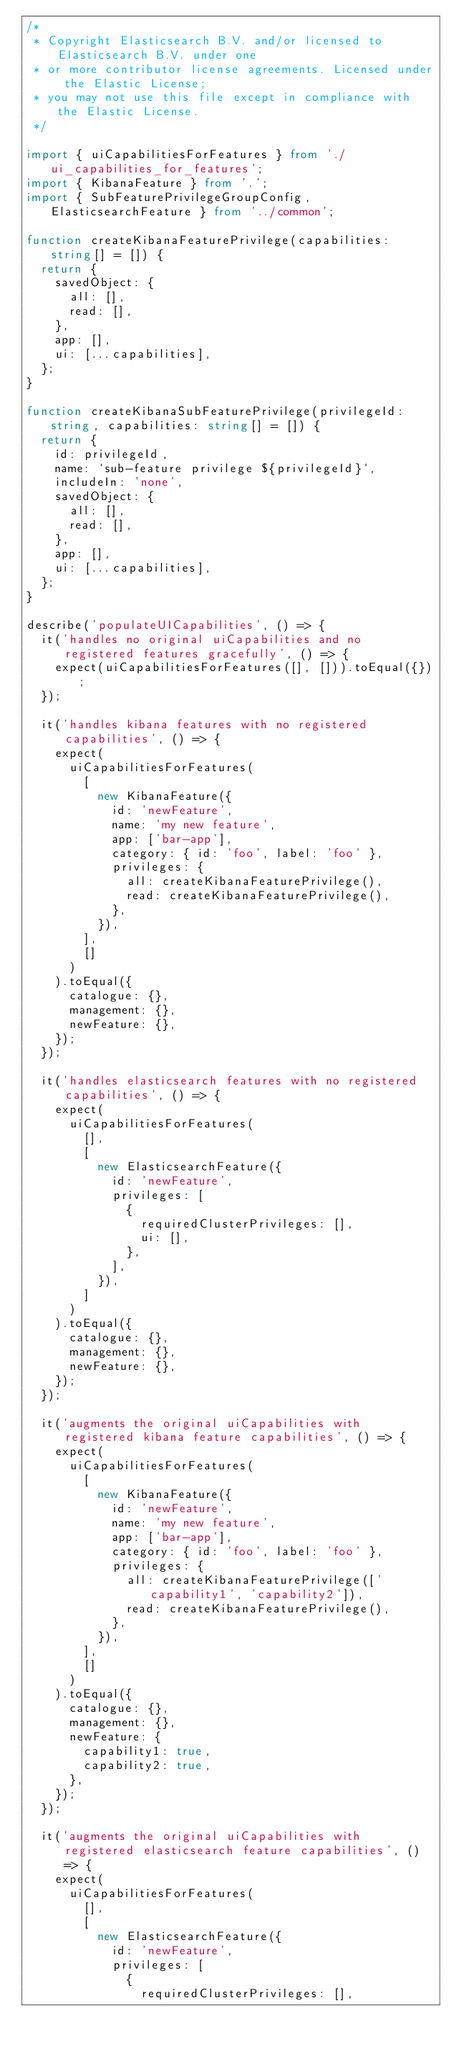Convert code to text. <code><loc_0><loc_0><loc_500><loc_500><_TypeScript_>/*
 * Copyright Elasticsearch B.V. and/or licensed to Elasticsearch B.V. under one
 * or more contributor license agreements. Licensed under the Elastic License;
 * you may not use this file except in compliance with the Elastic License.
 */

import { uiCapabilitiesForFeatures } from './ui_capabilities_for_features';
import { KibanaFeature } from '.';
import { SubFeaturePrivilegeGroupConfig, ElasticsearchFeature } from '../common';

function createKibanaFeaturePrivilege(capabilities: string[] = []) {
  return {
    savedObject: {
      all: [],
      read: [],
    },
    app: [],
    ui: [...capabilities],
  };
}

function createKibanaSubFeaturePrivilege(privilegeId: string, capabilities: string[] = []) {
  return {
    id: privilegeId,
    name: `sub-feature privilege ${privilegeId}`,
    includeIn: 'none',
    savedObject: {
      all: [],
      read: [],
    },
    app: [],
    ui: [...capabilities],
  };
}

describe('populateUICapabilities', () => {
  it('handles no original uiCapabilities and no registered features gracefully', () => {
    expect(uiCapabilitiesForFeatures([], [])).toEqual({});
  });

  it('handles kibana features with no registered capabilities', () => {
    expect(
      uiCapabilitiesForFeatures(
        [
          new KibanaFeature({
            id: 'newFeature',
            name: 'my new feature',
            app: ['bar-app'],
            category: { id: 'foo', label: 'foo' },
            privileges: {
              all: createKibanaFeaturePrivilege(),
              read: createKibanaFeaturePrivilege(),
            },
          }),
        ],
        []
      )
    ).toEqual({
      catalogue: {},
      management: {},
      newFeature: {},
    });
  });

  it('handles elasticsearch features with no registered capabilities', () => {
    expect(
      uiCapabilitiesForFeatures(
        [],
        [
          new ElasticsearchFeature({
            id: 'newFeature',
            privileges: [
              {
                requiredClusterPrivileges: [],
                ui: [],
              },
            ],
          }),
        ]
      )
    ).toEqual({
      catalogue: {},
      management: {},
      newFeature: {},
    });
  });

  it('augments the original uiCapabilities with registered kibana feature capabilities', () => {
    expect(
      uiCapabilitiesForFeatures(
        [
          new KibanaFeature({
            id: 'newFeature',
            name: 'my new feature',
            app: ['bar-app'],
            category: { id: 'foo', label: 'foo' },
            privileges: {
              all: createKibanaFeaturePrivilege(['capability1', 'capability2']),
              read: createKibanaFeaturePrivilege(),
            },
          }),
        ],
        []
      )
    ).toEqual({
      catalogue: {},
      management: {},
      newFeature: {
        capability1: true,
        capability2: true,
      },
    });
  });

  it('augments the original uiCapabilities with registered elasticsearch feature capabilities', () => {
    expect(
      uiCapabilitiesForFeatures(
        [],
        [
          new ElasticsearchFeature({
            id: 'newFeature',
            privileges: [
              {
                requiredClusterPrivileges: [],</code> 